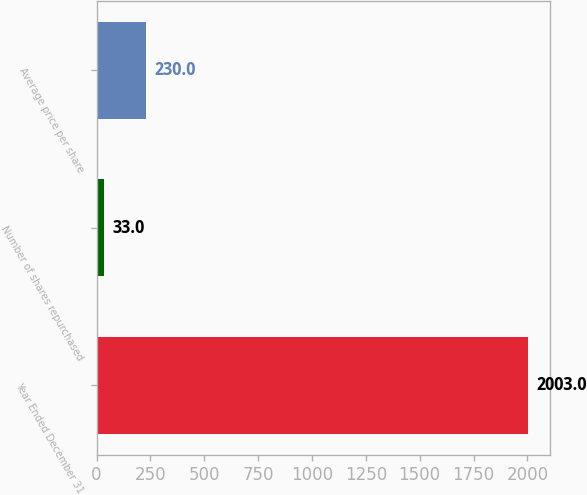<chart> <loc_0><loc_0><loc_500><loc_500><bar_chart><fcel>Year Ended December 31<fcel>Number of shares repurchased<fcel>Average price per share<nl><fcel>2003<fcel>33<fcel>230<nl></chart> 